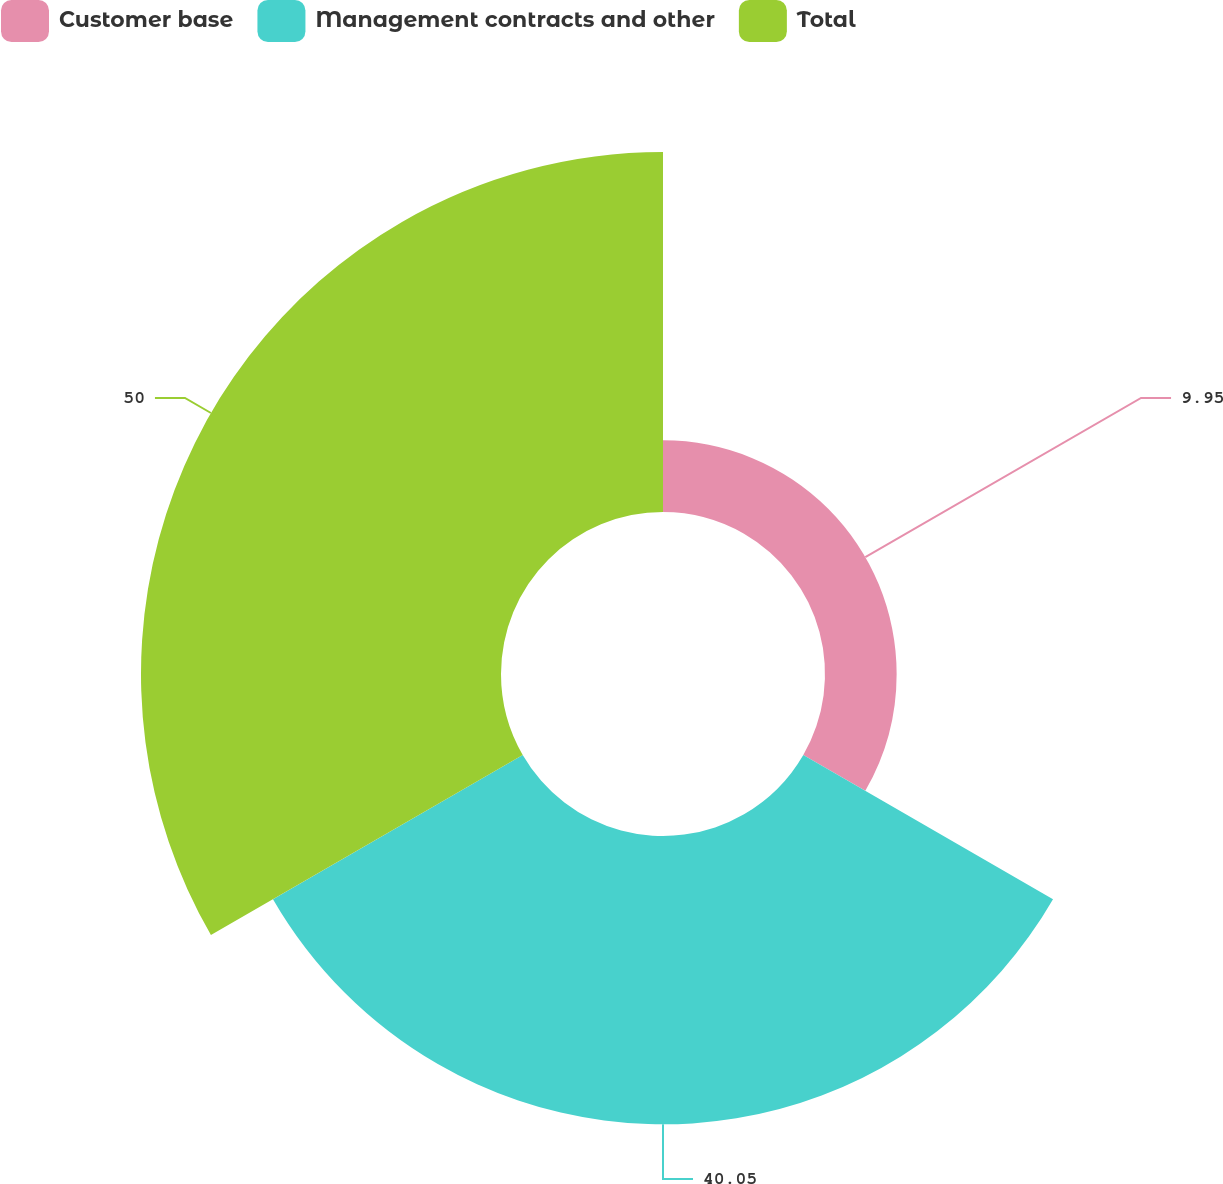Convert chart to OTSL. <chart><loc_0><loc_0><loc_500><loc_500><pie_chart><fcel>Customer base<fcel>Management contracts and other<fcel>Total<nl><fcel>9.95%<fcel>40.05%<fcel>50.0%<nl></chart> 